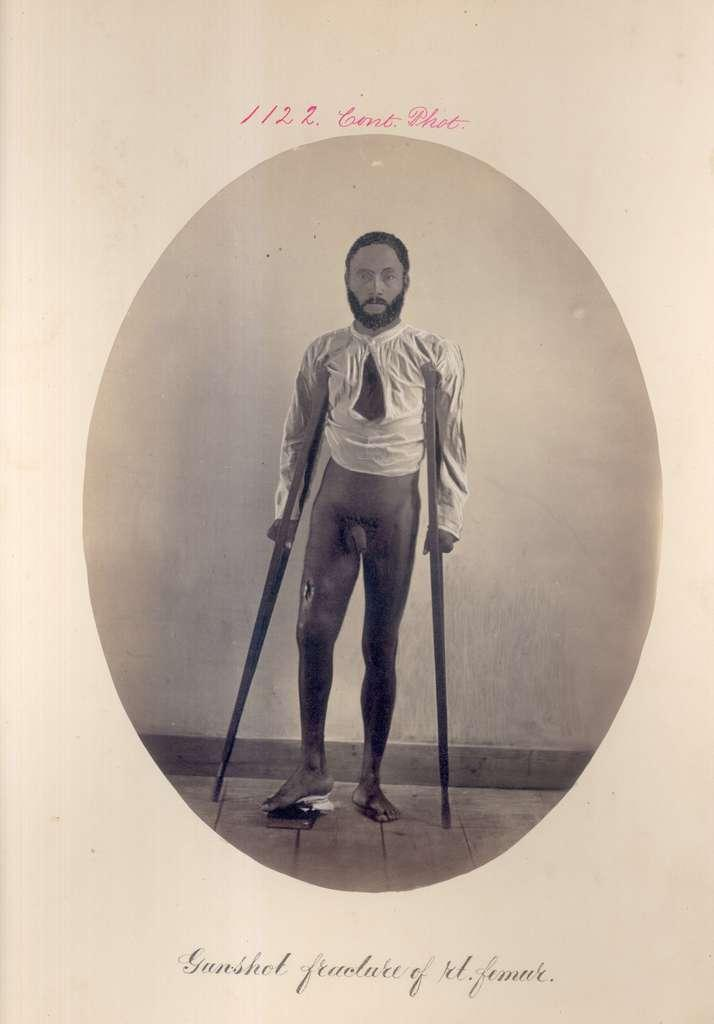What is present in the image that has a picture on it? There is a paper in the image that has a picture of a person. What else can be found on the paper besides the picture? There is text on the paper. How many hens are visible in the image? There are no hens present in the image. Is it raining in the image? There is no indication of rain in the image. 